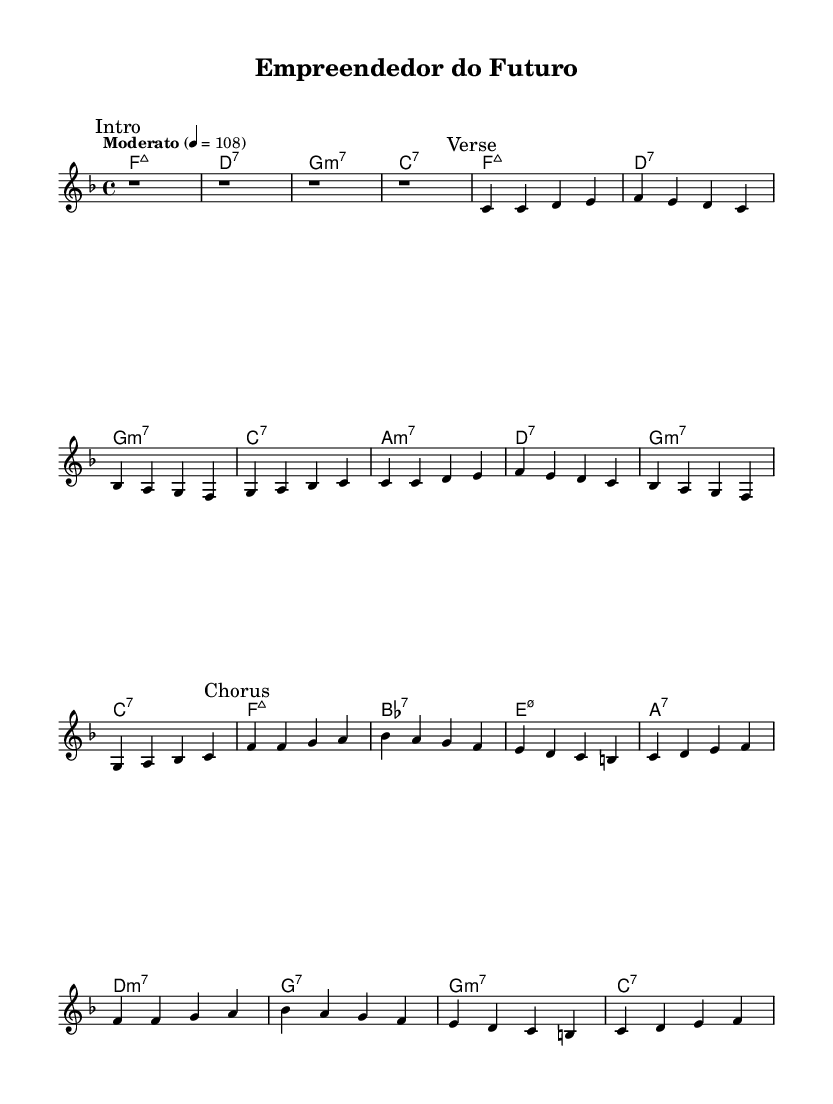What is the key signature of this music? The key signature is F major, which has one flat (B♭). This can be identified by looking at the beginning of the staff, where the flat symbol is placed before the note B.
Answer: F major What is the time signature used in this piece? The time signature is 4/4, which is indicated right after the key signature. It means there are four beats in each measure and a quarter note receives one beat.
Answer: 4/4 What is the tempo marking of the piece? The tempo marking states "Moderato" with a metronome mark of 108. This indicates that the piece should be played at a moderate speed, specifically 108 beats per minute.
Answer: Moderato, 108 How many measures are in the verse section? The verse section consists of two sets of four measures, making a total of eight measures. By counting the measures marked and the notes in that section, we arrive at this count.
Answer: 8 How many unique chords are used in the harmonies? There are six unique chords used in the harmonies: Fmaj7, D7, Gm7, C7, Am7, and B♭7. This is determined by identifying each chord in the chord mode section and counting them without duplicates.
Answer: 6 What is the primary theme of this music regarding its social context? The primary theme is urban entrepreneurship and social change, reflected in the title "Empreendedor do Futuro", which translates to "Entrepreneur of the Future." The piece may embody the spirit of innovation and community engagement in urban settings.
Answer: Urban entrepreneurship 